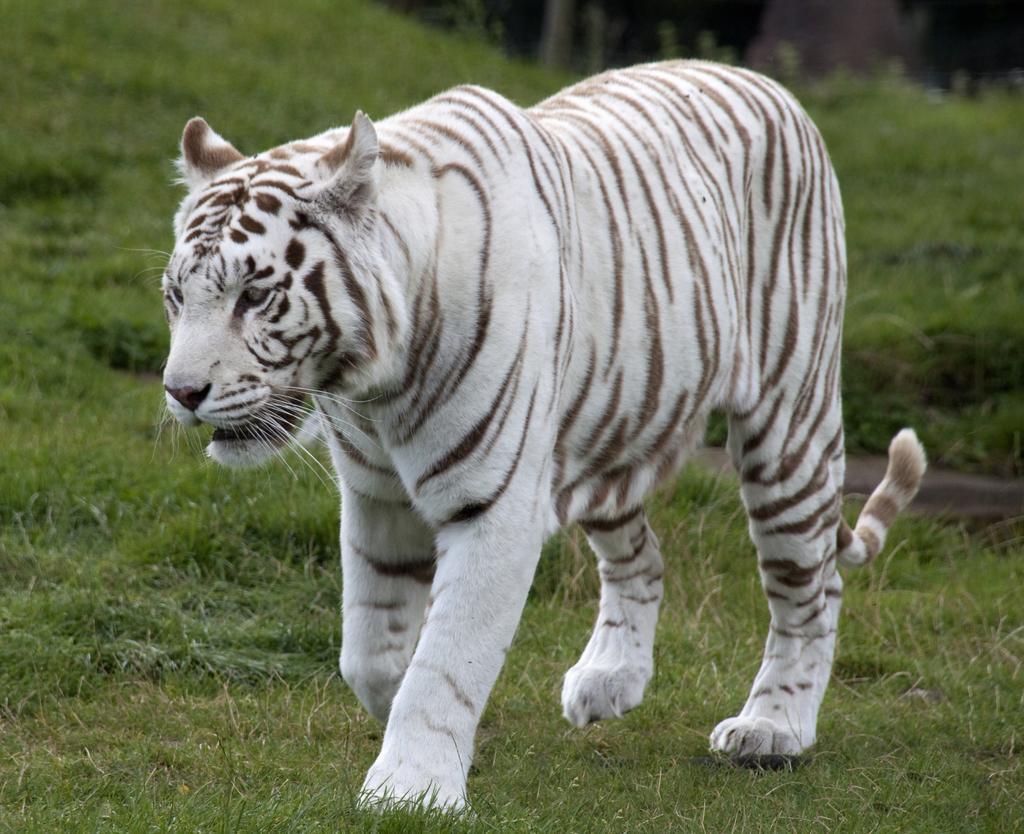Could you give a brief overview of what you see in this image? In the image we can see the white tiger and the grass. 